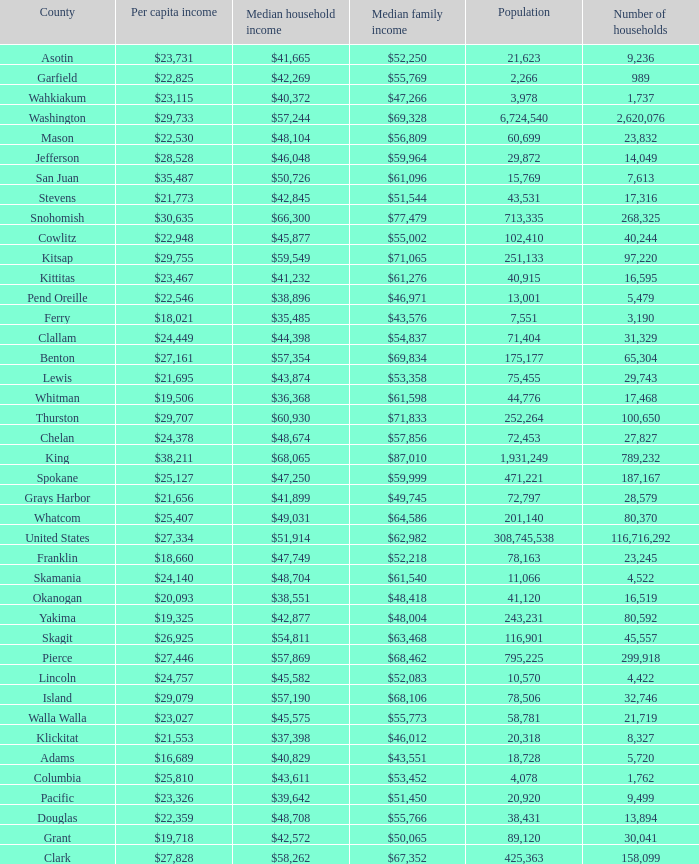How much is per capita income when median household income is $42,845? $21,773. 